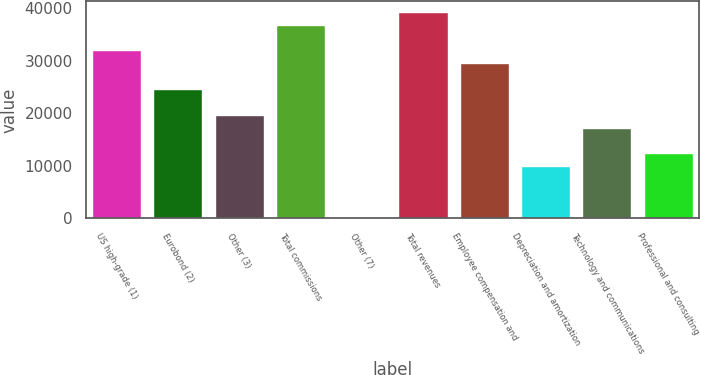<chart> <loc_0><loc_0><loc_500><loc_500><bar_chart><fcel>US high-grade (1)<fcel>Eurobond (2)<fcel>Other (3)<fcel>Total commissions<fcel>Other (7)<fcel>Total revenues<fcel>Employee compensation and<fcel>Depreciation and amortization<fcel>Technology and communications<fcel>Professional and consulting<nl><fcel>31968.8<fcel>24632<fcel>19740.8<fcel>36860<fcel>176<fcel>39305.6<fcel>29523.2<fcel>9958.4<fcel>17295.2<fcel>12404<nl></chart> 